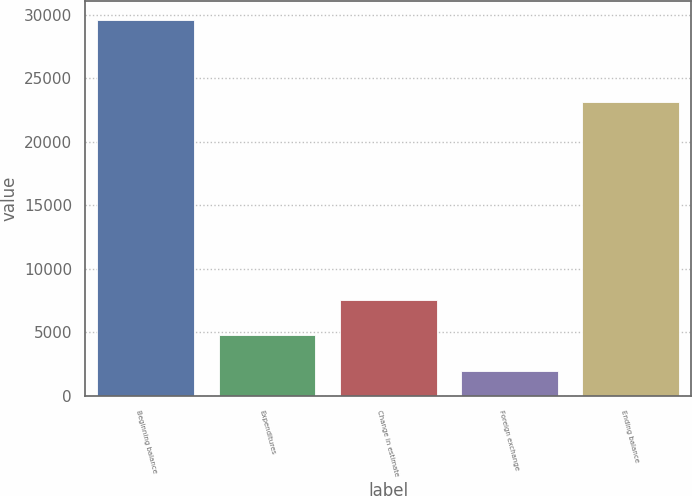Convert chart to OTSL. <chart><loc_0><loc_0><loc_500><loc_500><bar_chart><fcel>Beginning balance<fcel>Expenditures<fcel>Change in estimate<fcel>Foreign exchange<fcel>Ending balance<nl><fcel>29571<fcel>4756.2<fcel>7513.4<fcel>1999<fcel>23116<nl></chart> 